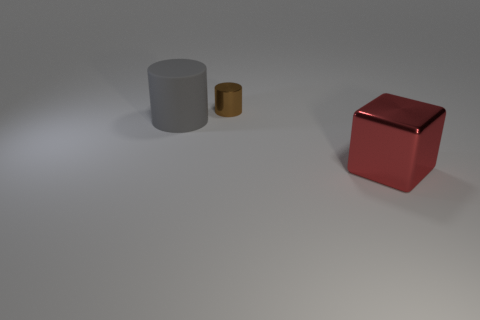How many objects are big things to the right of the large gray object or metal things that are in front of the gray thing?
Keep it short and to the point. 1. Do the red object and the matte thing have the same size?
Keep it short and to the point. Yes. How many balls are large metallic objects or large objects?
Your response must be concise. 0. What number of things are both on the left side of the red object and to the right of the large cylinder?
Provide a succinct answer. 1. Do the brown cylinder and the metallic object in front of the rubber object have the same size?
Your answer should be very brief. No. There is a object in front of the big object that is behind the large red metallic block; are there any big red blocks that are behind it?
Offer a terse response. No. What material is the cylinder that is in front of the metallic thing behind the gray object?
Ensure brevity in your answer.  Rubber. The object that is on the right side of the large cylinder and in front of the small brown shiny thing is made of what material?
Provide a succinct answer. Metal. Are there any small brown things that have the same shape as the red metal object?
Offer a very short reply. No. Are there any large gray rubber things that are behind the small brown cylinder that is to the right of the gray rubber thing?
Your answer should be very brief. No. 